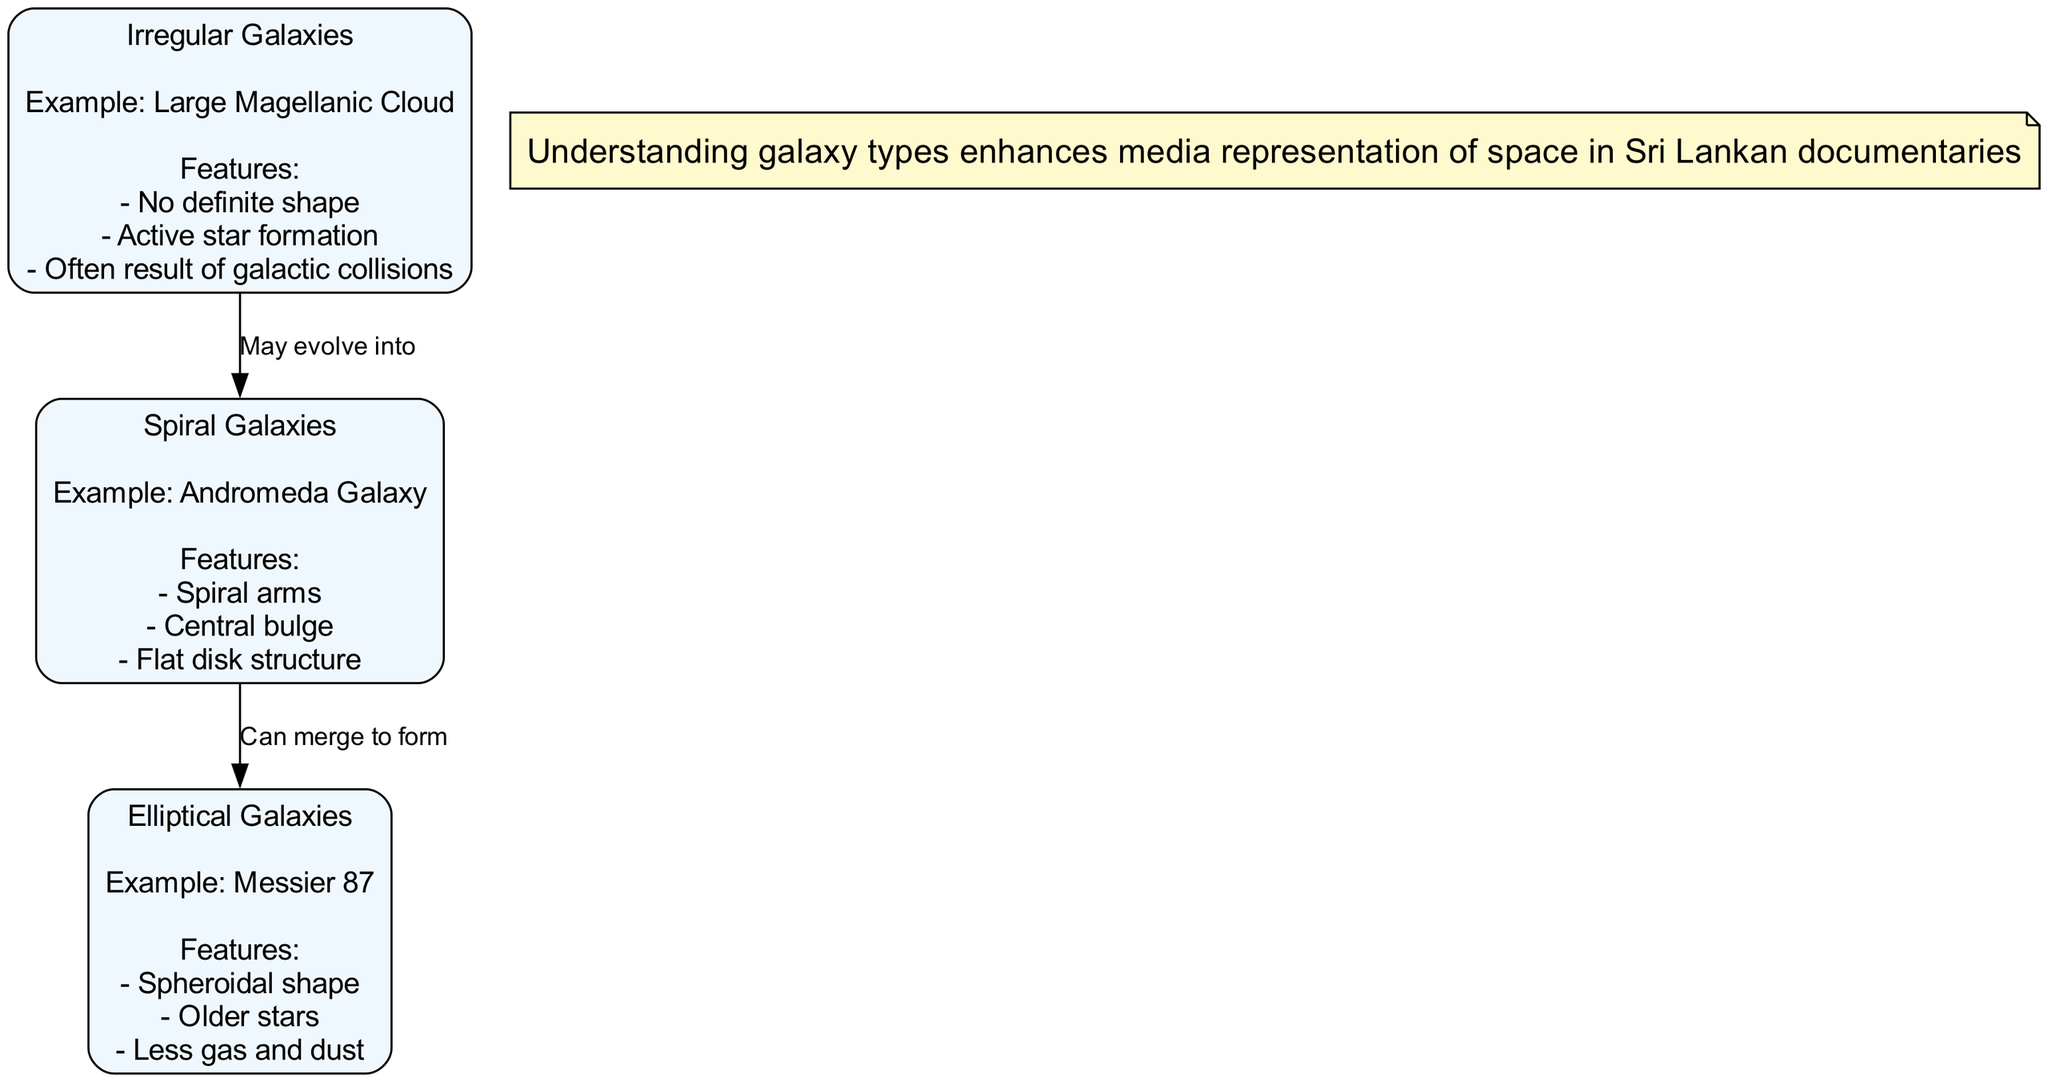What is the example of Spiral Galaxy? The diagram indicates that the example of a Spiral Galaxy is the Andromeda Galaxy, listed directly under the Spiral Galaxies node.
Answer: Andromeda Galaxy How many types of galaxies are shown in the diagram? The diagram presents three types of galaxies: Spiral, Elliptical, and Irregular, which can be counted by looking at the distinct nodes labeled with each type.
Answer: Three What are the main features of Elliptical Galaxies? By examining the Elliptical Galaxies node, the features listed are Spheroidal shape, Older stars, and Less gas and dust, which can be gathered from the features section.
Answer: Spheroidal shape, Older stars, Less gas and dust Which galaxy type may evolve into Spiral Galaxies? The Irregular Galaxies node indicates that this type may evolve into Spiral Galaxies, as illustrated by the connection labeled "May evolve into."
Answer: Irregular Galaxies What relationship is depicted between Spiral Galaxies and Elliptical Galaxies? The diagram shows a directed connection from Spiral Galaxies to Elliptical Galaxies labeled "Can merge to form," indicating a specific relationship.
Answer: Can merge to form What is the distinct feature of Irregular Galaxies? The distinguishing feature outlined under Irregular Galaxies is that they have no definite shape, explicitly mentioned as one of their main features.
Answer: No definite shape Which type of galaxy is Messier 87 an example of? The diagram provides that Messier 87 is an example under the Elliptical Galaxies node, as clearly stated in the accompanying label.
Answer: Elliptical Galaxies How does understanding galaxy types benefit Sri Lankan documentaries? The diagram's contextual note suggests that understanding galaxy types enhances the media representation of space in Sri Lankan documentaries by providing deeper context and accuracy.
Answer: Enhances media representation of space 